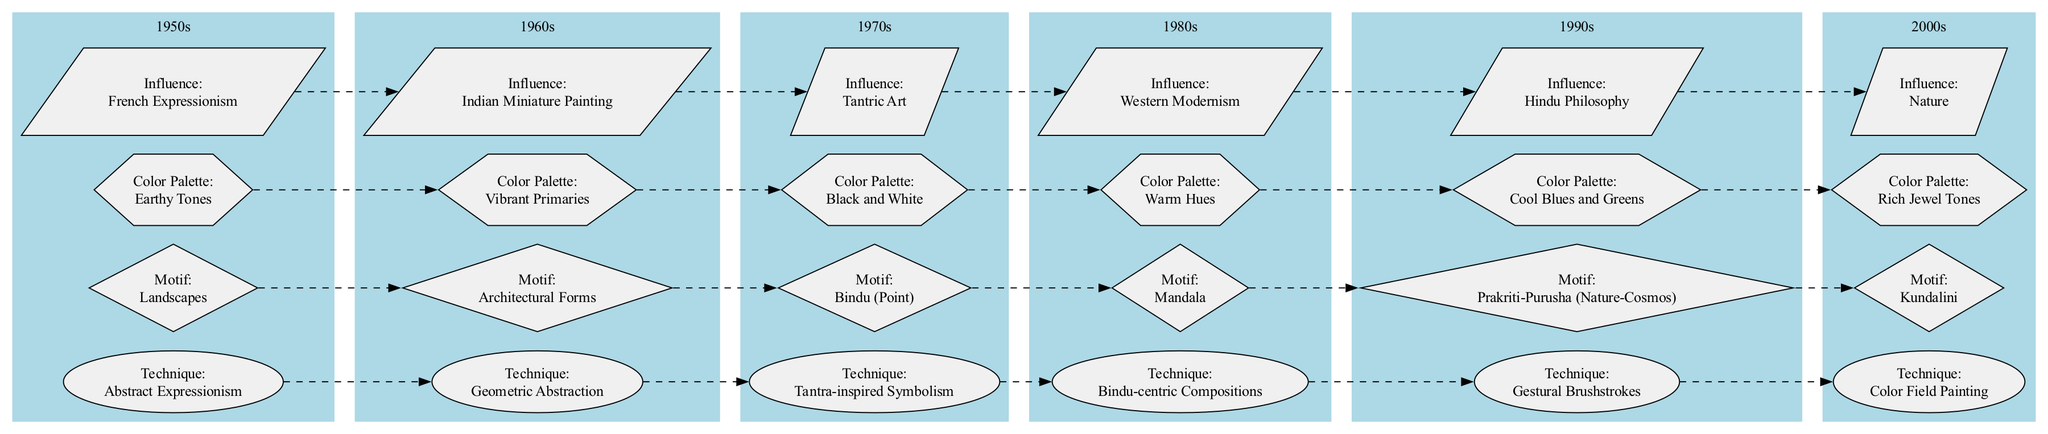What technique does Raza employ in the 1970s? The 1970s node has a specific label indicating the technique used during this decade, which is "Tantra-inspired Symbolism."
Answer: Tantra-inspired Symbolism Which decade features "Kundalini" as a motif? By checking the nodes under each decade cluster, the 2000s node specifies "Kundalini" as the motif used during that decade.
Answer: 2000s What is the color palette of Raza's paintings in the 1990s? The node for the 1990s states the color palette as "Cool Blues and Greens," which is clearly indicated next to that decade's label.
Answer: Cool Blues and Greens How many influences are listed for Raza's work? Count the influence nodes within the diagram, each decade has one influence node. Since there are six decades, there are six influences.
Answer: 6 Which two decades show a transition from "Abstract Expressionism" to "Geometric Abstraction"? Trace the connections in the diagram from the 1950s, where "Abstract Expressionism" is noted, to the 1960s node which connects to "Geometric Abstraction."
Answer: 1950s to 1960s What motif appears in the 1980s decade? The 1980s node has a specified motif labeled "Mandala," which identifies the main artistic motif of that period.
Answer: Mandala Which colors dominate Raza's paintings in the 2000s? The node for the 2000s decade includes the label "Rich Jewel Tones," identifying the main colors used by Raza during that time.
Answer: Rich Jewel Tones How does the influence of "Hindu Philosophy" relate to Raza's technique in the 1970s? The explanation requires looking at the nodes’ relationships. The 1970s influence lists "Hindu Philosophy," which suggests this philosophical context influences his use of "Tantra-inspired Symbolism," also listed in the same node.
Answer: Hindu Philosophy influences Tantra-inspired Symbolism What technique is associated with landscapes in the 1950s? The 1950s node specifies "Abstract Expressionism" as the technique, while also showing "Landscapes" as the motif associated with that decade. Thus, landscapes are depicted using this technique.
Answer: Abstract Expressionism 